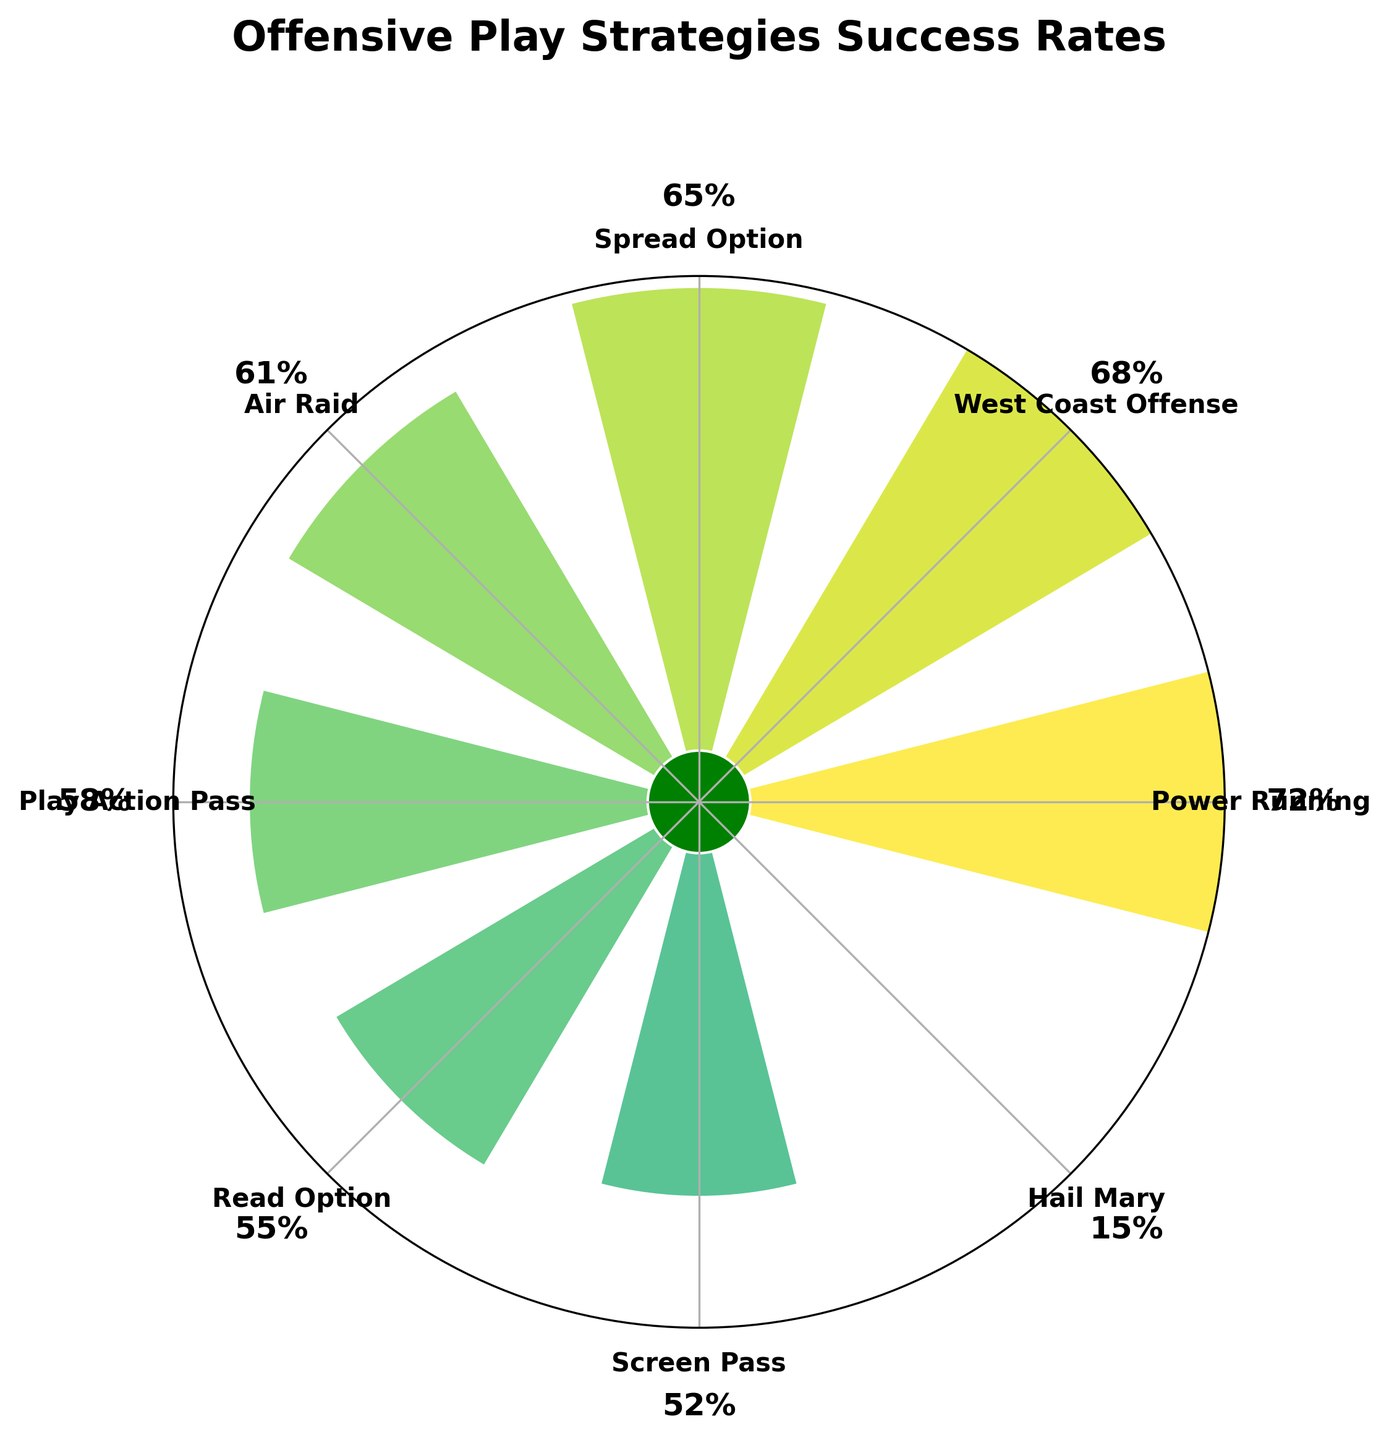Which offensive play strategy has the highest success rate? The Power Running play strategy is marked at 72%, which is the highest value displayed.
Answer: Power Running Which offensive play strategy has the lowest success rate? The Hail Mary play strategy is marked at 15%, making it the lowest value displayed.
Answer: Hail Mary What is the title of the plot? The title is displayed at the top of the plot and reads "Offensive Play Strategies Success Rates".
Answer: Offensive Play Strategies Success Rates How many offensive play strategies are displayed in the plot? Count the number of distinct segments or labels around the gauge chart; there are 8 segments or strategies.
Answer: 8 Compare the success rates of the Spread Option and the Air Raid strategies. Which has a higher success rate? The Spread Option has a success rate of 65%, while the Air Raid has a success rate of 61%. 65% is greater than 61%.
Answer: Spread Option What is the average success rate of all the offensive play strategies shown? Sum all the success rates (72 + 68 + 65 + 61 + 58 + 55 + 52 + 15) = 446, then divide by the number of strategies (8). The average is 446 / 8 = 55.75.
Answer: 55.75 What is the difference in success rate between the Power Running and Screen Pass strategies? The success rates for Power Running and Screen Pass are 72% and 52% respectively. The difference is 72 - 52 = 20%.
Answer: 20% What strategy has close to a 55% success rate? The Read Option is the closest with a success rate of 55%.
Answer: Read Option What color is the bar for the West Coast Offense strategy? The West Coast Offense bar, indicated at 68%, appears in varying shades of the colormap viridis, often greenish.
Answer: greenish Identify two strategies with success rates over 70%. Only Power Running has a success rate over 70%, at 72%. There are no other strategies with success rates over 70%.
Answer: Power Running 